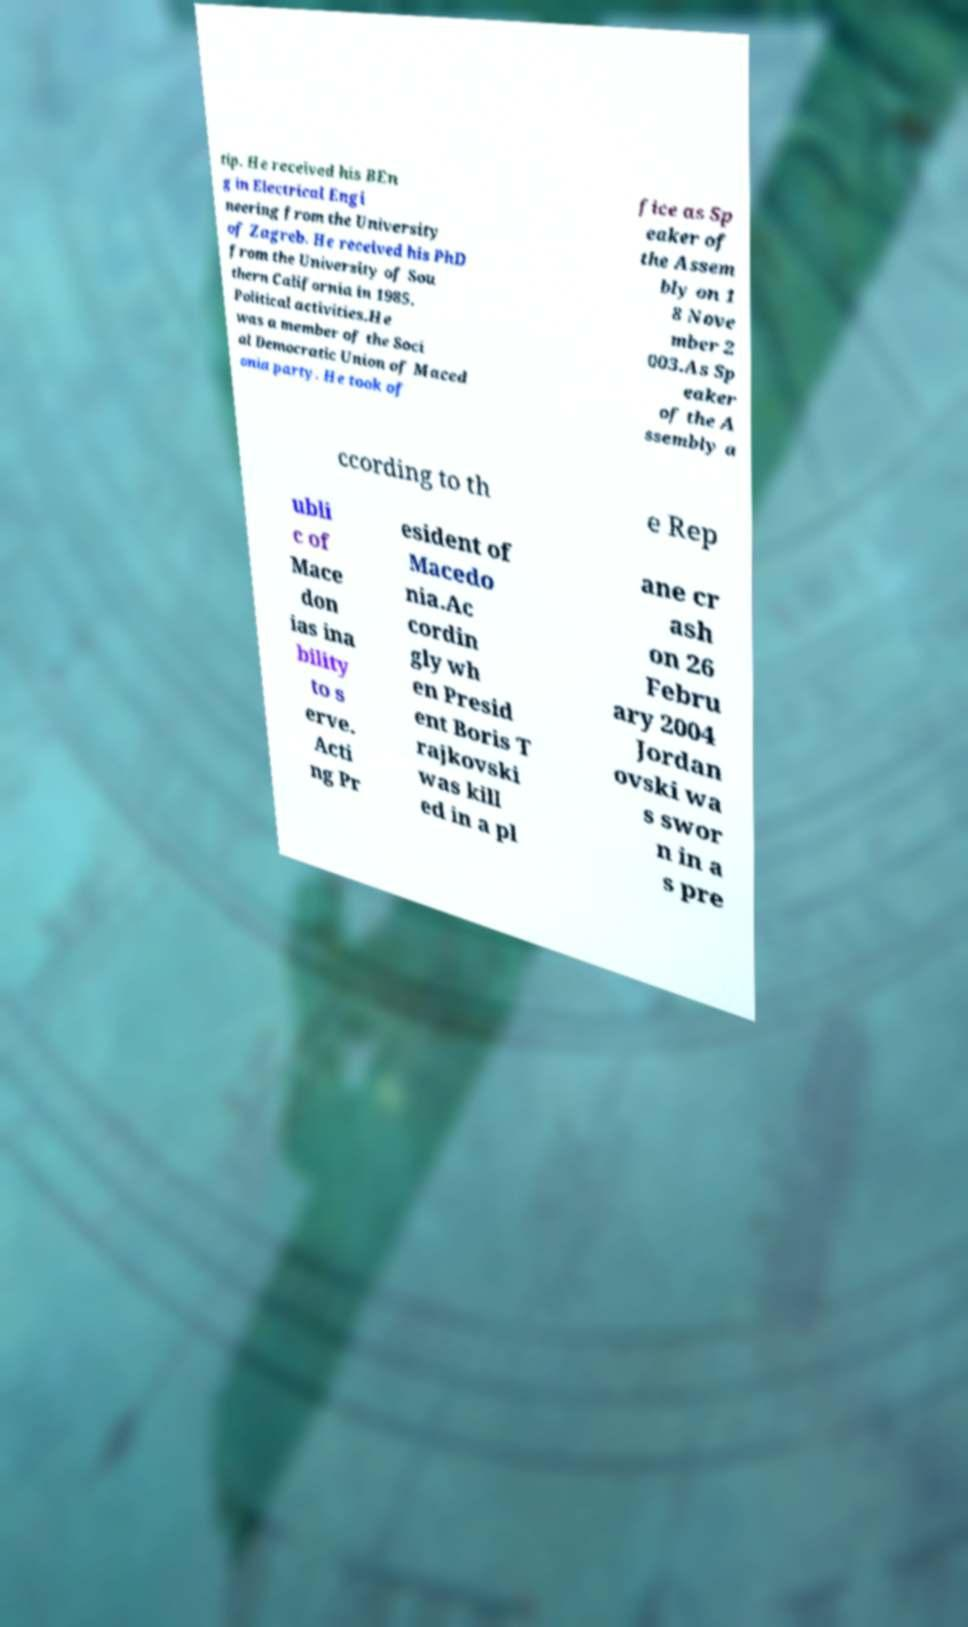Please identify and transcribe the text found in this image. tip. He received his BEn g in Electrical Engi neering from the University of Zagreb. He received his PhD from the University of Sou thern California in 1985. Political activities.He was a member of the Soci al Democratic Union of Maced onia party. He took of fice as Sp eaker of the Assem bly on 1 8 Nove mber 2 003.As Sp eaker of the A ssembly a ccording to th e Rep ubli c of Mace don ias ina bility to s erve. Acti ng Pr esident of Macedo nia.Ac cordin gly wh en Presid ent Boris T rajkovski was kill ed in a pl ane cr ash on 26 Febru ary 2004 Jordan ovski wa s swor n in a s pre 